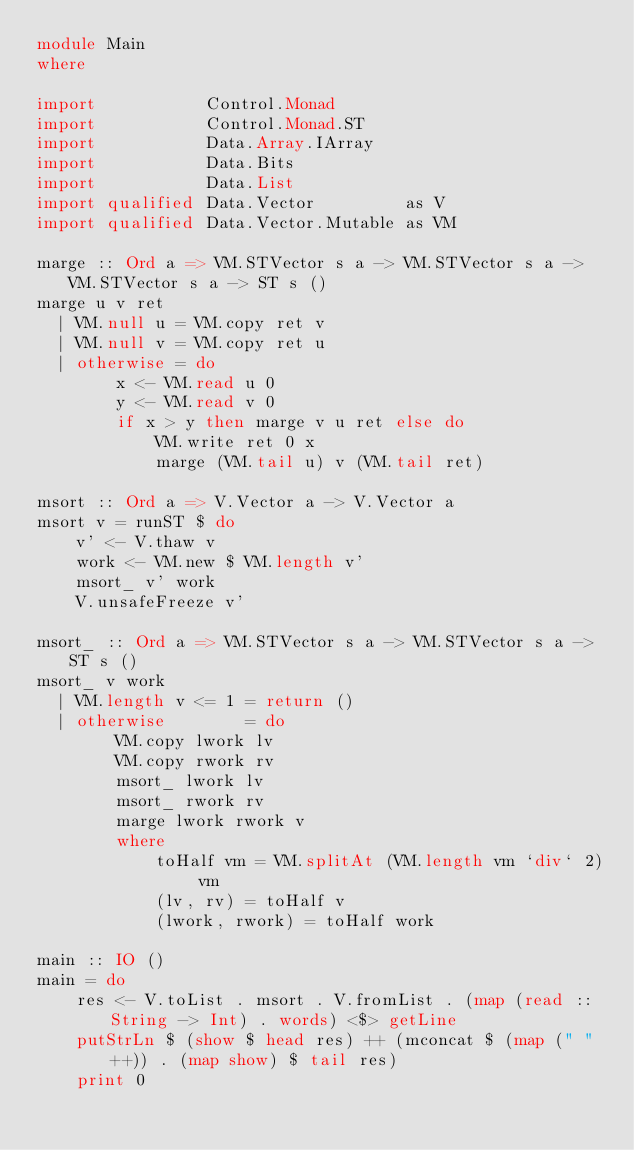Convert code to text. <code><loc_0><loc_0><loc_500><loc_500><_Haskell_>module Main
where

import           Control.Monad
import           Control.Monad.ST
import           Data.Array.IArray
import           Data.Bits
import           Data.List
import qualified Data.Vector         as V
import qualified Data.Vector.Mutable as VM

marge :: Ord a => VM.STVector s a -> VM.STVector s a -> VM.STVector s a -> ST s ()
marge u v ret
  | VM.null u = VM.copy ret v
  | VM.null v = VM.copy ret u
  | otherwise = do
        x <- VM.read u 0
        y <- VM.read v 0
        if x > y then marge v u ret else do
            VM.write ret 0 x
            marge (VM.tail u) v (VM.tail ret)

msort :: Ord a => V.Vector a -> V.Vector a
msort v = runST $ do
    v' <- V.thaw v
    work <- VM.new $ VM.length v'
    msort_ v' work
    V.unsafeFreeze v'

msort_ :: Ord a => VM.STVector s a -> VM.STVector s a -> ST s ()
msort_ v work
  | VM.length v <= 1 = return ()
  | otherwise        = do
        VM.copy lwork lv
        VM.copy rwork rv
        msort_ lwork lv
        msort_ rwork rv
        marge lwork rwork v
        where
            toHalf vm = VM.splitAt (VM.length vm `div` 2) vm
            (lv, rv) = toHalf v
            (lwork, rwork) = toHalf work

main :: IO ()
main = do
    res <- V.toList . msort . V.fromList . (map (read :: String -> Int) . words) <$> getLine
    putStrLn $ (show $ head res) ++ (mconcat $ (map (" " ++)) . (map show) $ tail res)
    print 0
</code> 